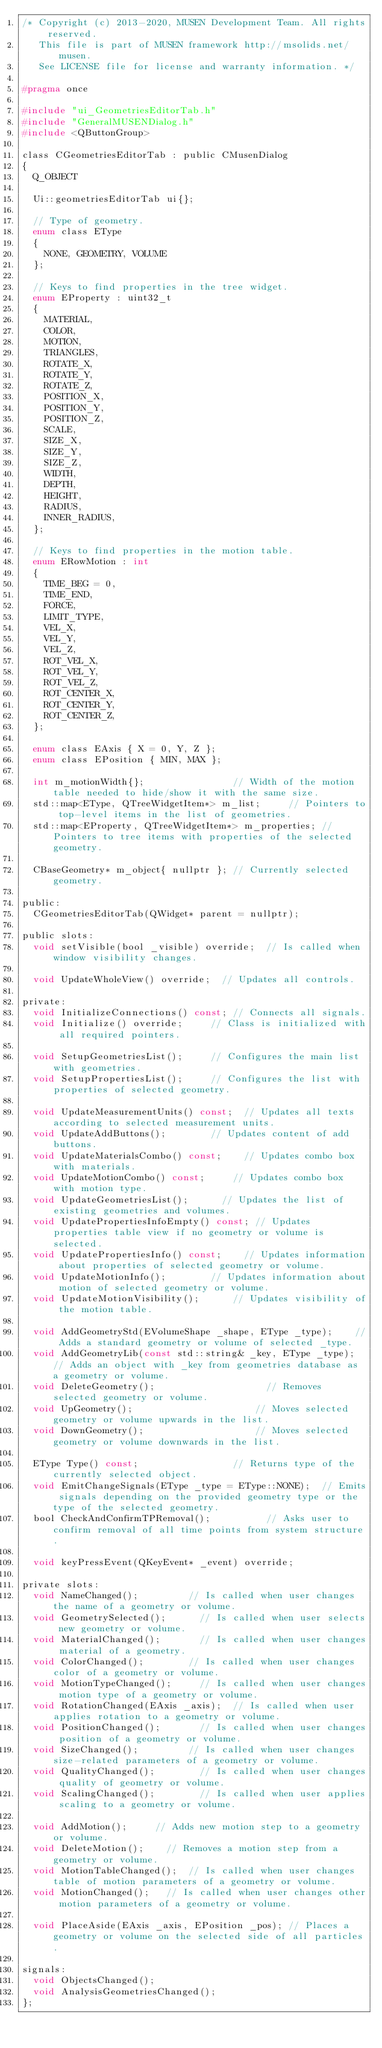<code> <loc_0><loc_0><loc_500><loc_500><_C_>/* Copyright (c) 2013-2020, MUSEN Development Team. All rights reserved.
   This file is part of MUSEN framework http://msolids.net/musen.
   See LICENSE file for license and warranty information. */

#pragma once

#include "ui_GeometriesEditorTab.h"
#include "GeneralMUSENDialog.h"
#include <QButtonGroup>

class CGeometriesEditorTab : public CMusenDialog
{
	Q_OBJECT

	Ui::geometriesEditorTab ui{};

	// Type of geometry.
	enum class EType
	{
		NONE, GEOMETRY, VOLUME
	};

	// Keys to find properties in the tree widget.
	enum EProperty : uint32_t
	{
		MATERIAL,
		COLOR,
		MOTION,
		TRIANGLES,
		ROTATE_X,
		ROTATE_Y,
		ROTATE_Z,
		POSITION_X,
		POSITION_Y,
		POSITION_Z,
		SCALE,
		SIZE_X,
		SIZE_Y,
		SIZE_Z,
		WIDTH,
		DEPTH,
		HEIGHT,
		RADIUS,
		INNER_RADIUS,
	};

	// Keys to find properties in the motion table.
	enum ERowMotion : int
	{
		TIME_BEG = 0,
		TIME_END,
		FORCE,
		LIMIT_TYPE,
		VEL_X,
		VEL_Y,
		VEL_Z,
		ROT_VEL_X,
		ROT_VEL_Y,
		ROT_VEL_Z,
		ROT_CENTER_X,
		ROT_CENTER_Y,
		ROT_CENTER_Z,
	};

	enum class EAxis { X = 0, Y, Z };
	enum class EPosition { MIN, MAX };

	int m_motionWidth{};								// Width of the motion table needed to hide/show it with the same size.
	std::map<EType, QTreeWidgetItem*> m_list;			// Pointers to top-level items in the list of geometries.
	std::map<EProperty, QTreeWidgetItem*> m_properties;	// Pointers to tree items with properties of the selected geometry.

	CBaseGeometry* m_object{ nullptr };	// Currently selected geometry.

public:
	CGeometriesEditorTab(QWidget* parent = nullptr);

public slots:
	void setVisible(bool _visible) override;	// Is called when window visibility changes.

	void UpdateWholeView() override;	// Updates all controls.

private:
	void InitializeConnections() const;	// Connects all signals.
	void Initialize() override;			// Class is initialized with all required pointers.

	void SetupGeometriesList();			// Configures the main list with geometries.
	void SetupPropertiesList();			// Configures the list with properties of selected geometry.

	void UpdateMeasurementUnits() const;	// Updates all texts according to selected measurement units.
	void UpdateAddButtons();				// Updates content of add buttons.
	void UpdateMaterialsCombo() const;		// Updates combo box with materials.
	void UpdateMotionCombo() const;			// Updates combo box with motion type.
	void UpdateGeometriesList();			// Updates the list of existing geometries and volumes.
	void UpdatePropertiesInfoEmpty() const;	// Updates properties table view if no geometry or volume is selected.
	void UpdatePropertiesInfo() const;		// Updates information about properties of selected geometry or volume.
	void UpdateMotionInfo();				// Updates information about motion of selected geometry or volume.
	void UpdateMotionVisibility();			// Updates visibility of the motion table.

	void AddGeometryStd(EVolumeShape _shape, EType _type);		// Adds a standard geometry or volume of selected _type.
	void AddGeometryLib(const std::string& _key, EType _type);	// Adds an object with _key from geometries database as a geometry or volume.
	void DeleteGeometry();										// Removes selected geometry or volume.
	void UpGeometry();											// Moves selected geometry or volume upwards in the list.
	void DownGeometry();										// Moves selected geometry or volume downwards in the list.

	EType Type() const;									// Returns type of the currently selected object.
	void EmitChangeSignals(EType _type = EType::NONE);	// Emits signals depending on the provided geometry type or the type of the selected geometry.
	bool CheckAndConfirmTPRemoval();					// Asks user to confirm removal of all time points from system structure.

	void keyPressEvent(QKeyEvent* _event) override;

private slots:
	void NameChanged();					// Is called when user changes the name of a geometry or volume.
	void GeometrySelected();			// Is called when user selects new geometry or volume.
	void MaterialChanged();				// Is called when user changes material of a geometry.
	void ColorChanged();				// Is called when user changes color of a geometry or volume.
	void MotionTypeChanged();			// Is called when user changes motion type of a geometry or volume.
	void RotationChanged(EAxis _axis);	// Is called when user applies rotation to a geometry or volume.
	void PositionChanged();				// Is called when user changes position of a geometry or volume.
	void SizeChanged();					// Is called when user changes size-related parameters of a geometry or volume.
	void QualityChanged();				// Is called when user changes quality of geometry or volume.
	void ScalingChanged();				// Is called when user applies scaling to a geometry or volume.

	void AddMotion();			// Adds new motion step to a geometry or volume.
	void DeleteMotion();		// Removes a motion step from a geometry or volume.
	void MotionTableChanged();	// Is called when user changes table of motion parameters of a geometry or volume.
	void MotionChanged();		// Is called when user changes other motion parameters of a geometry or volume.

	void PlaceAside(EAxis _axis, EPosition _pos); // Places a geometry or volume on the selected side of all particles.

signals:
	void ObjectsChanged();
	void AnalysisGeometriesChanged();
};
</code> 